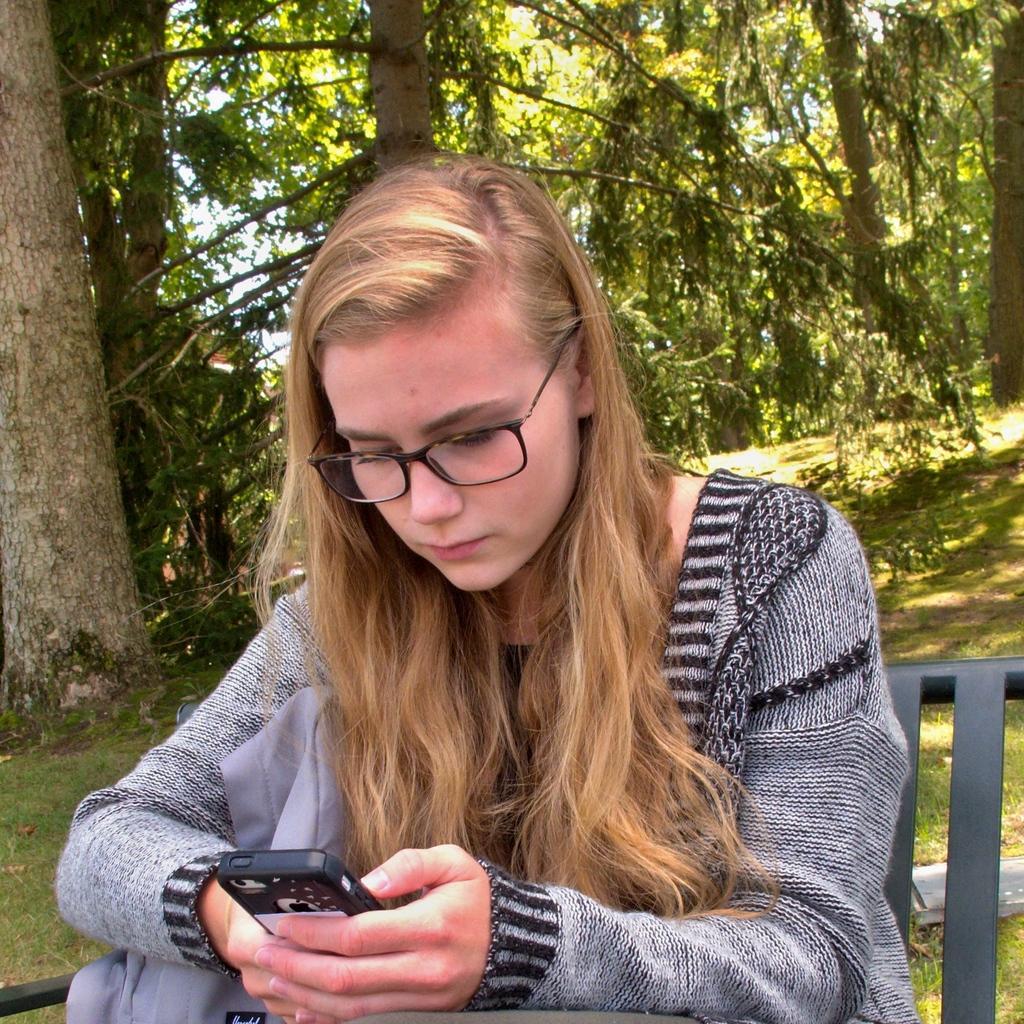Describe this image in one or two sentences. Here we can see a woman is sitting on the chair, and holding a mobile in her hands, and at back here are the trees, and here is the grass. 